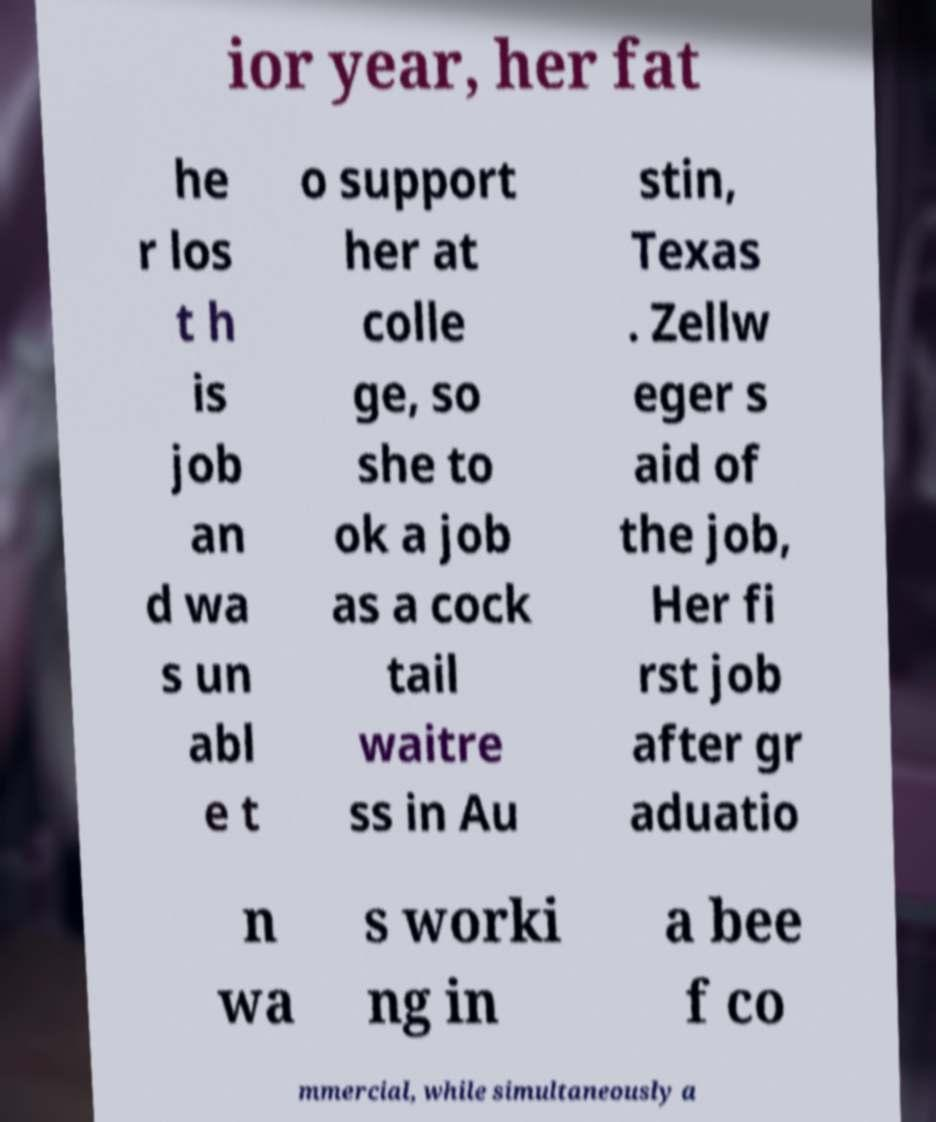Could you assist in decoding the text presented in this image and type it out clearly? ior year, her fat he r los t h is job an d wa s un abl e t o support her at colle ge, so she to ok a job as a cock tail waitre ss in Au stin, Texas . Zellw eger s aid of the job, Her fi rst job after gr aduatio n wa s worki ng in a bee f co mmercial, while simultaneously a 